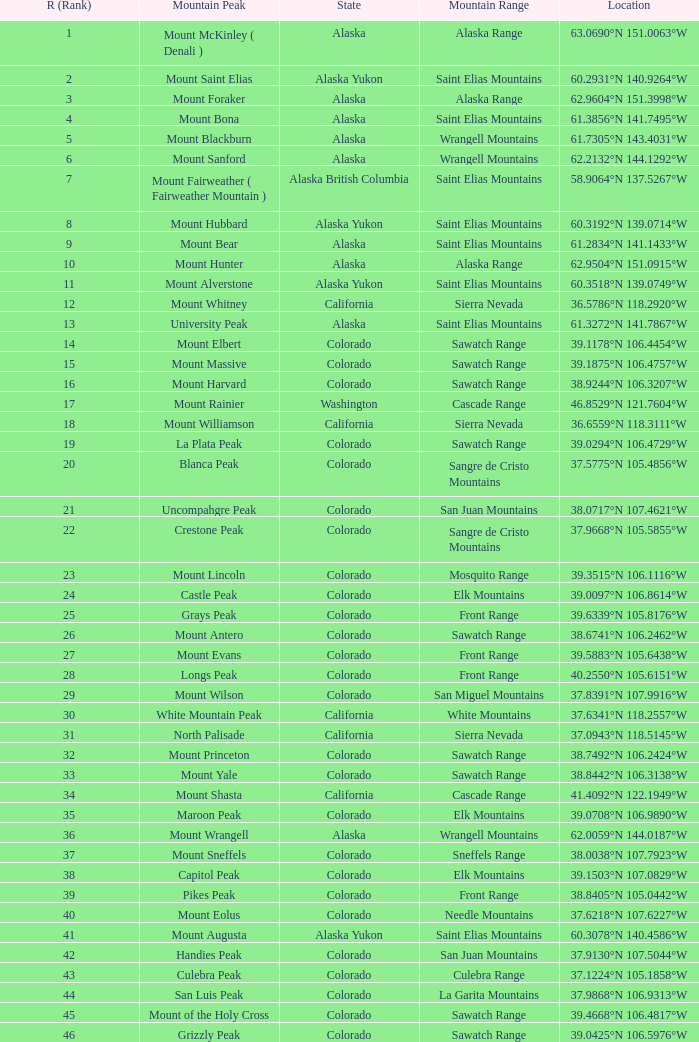What is the rank when the state is colorado and the location is 37.7859°n 107.7039°w? 83.0. 